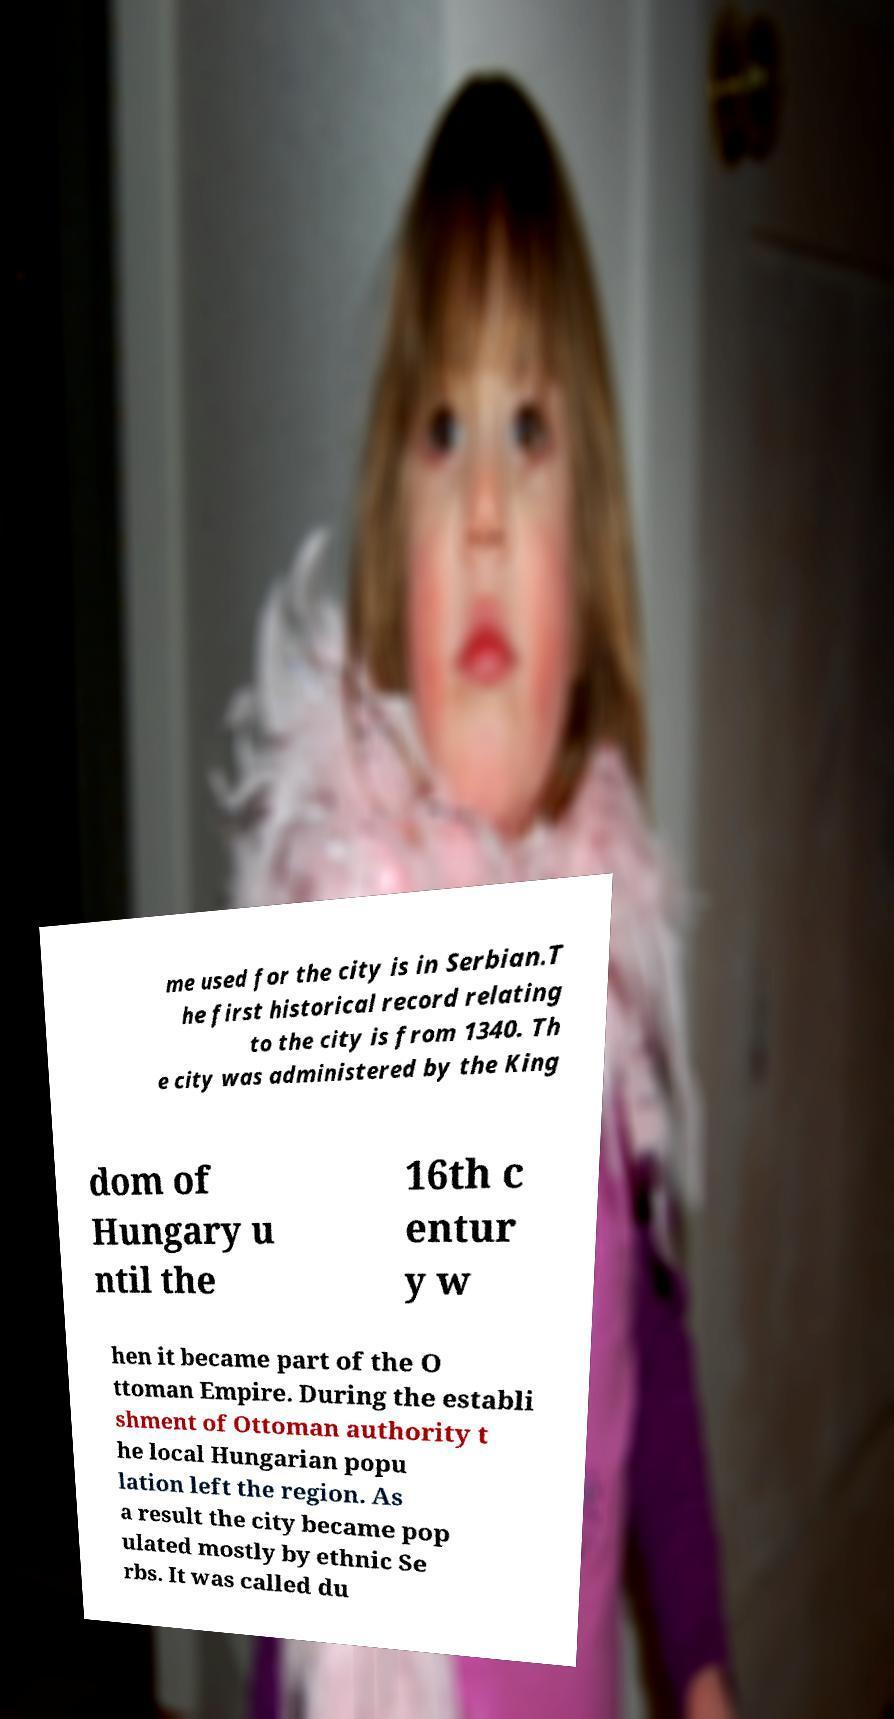What messages or text are displayed in this image? I need them in a readable, typed format. me used for the city is in Serbian.T he first historical record relating to the city is from 1340. Th e city was administered by the King dom of Hungary u ntil the 16th c entur y w hen it became part of the O ttoman Empire. During the establi shment of Ottoman authority t he local Hungarian popu lation left the region. As a result the city became pop ulated mostly by ethnic Se rbs. It was called du 